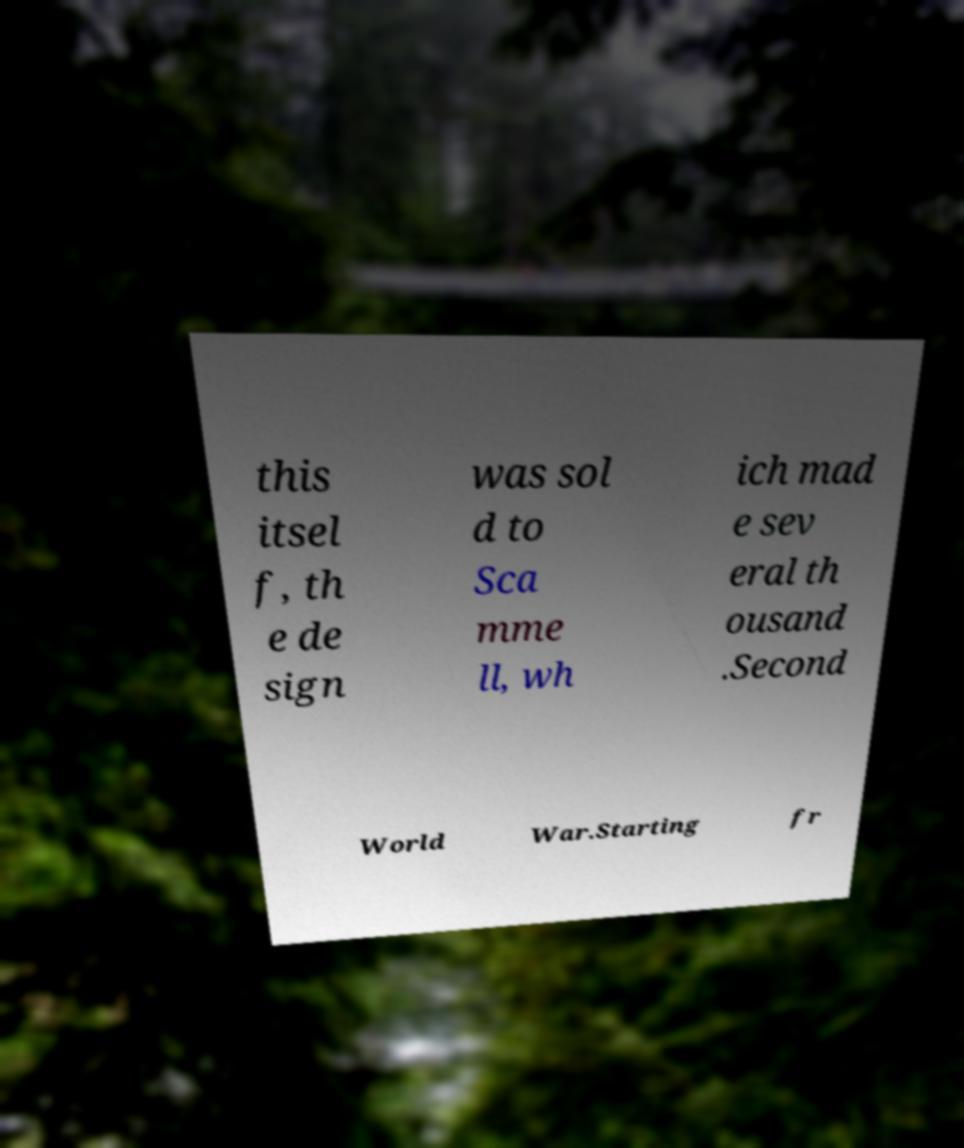Can you read and provide the text displayed in the image?This photo seems to have some interesting text. Can you extract and type it out for me? this itsel f, th e de sign was sol d to Sca mme ll, wh ich mad e sev eral th ousand .Second World War.Starting fr 